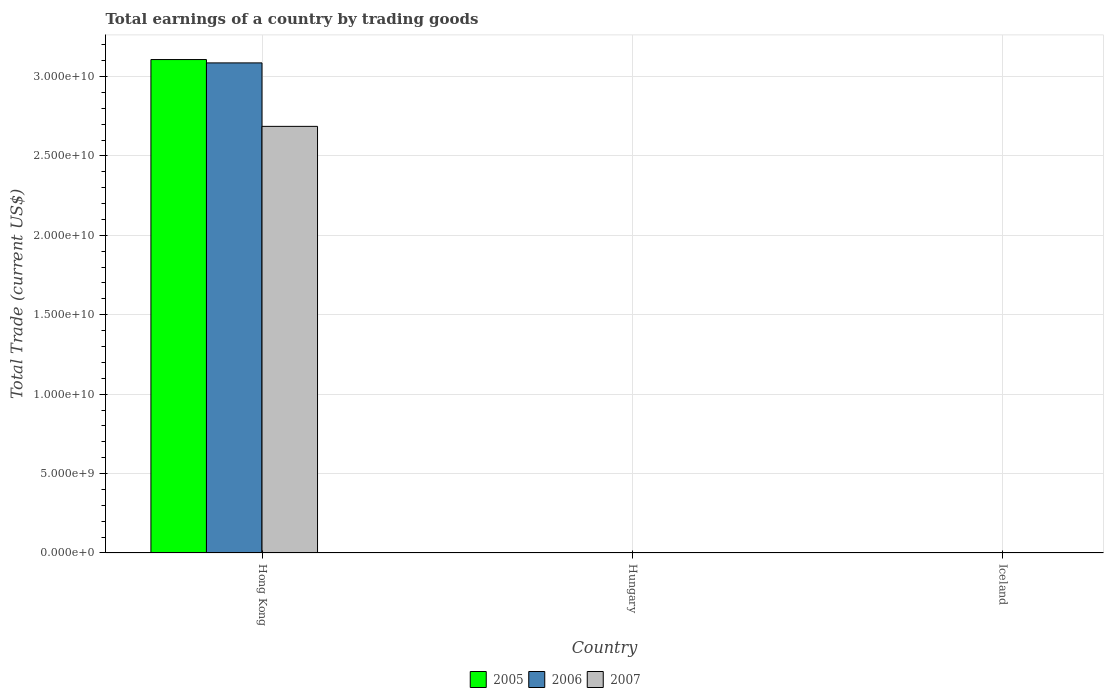Are the number of bars per tick equal to the number of legend labels?
Ensure brevity in your answer.  No. Are the number of bars on each tick of the X-axis equal?
Give a very brief answer. No. How many bars are there on the 3rd tick from the left?
Provide a short and direct response. 0. What is the label of the 1st group of bars from the left?
Your answer should be very brief. Hong Kong. What is the total earnings in 2007 in Hong Kong?
Make the answer very short. 2.69e+1. Across all countries, what is the maximum total earnings in 2006?
Give a very brief answer. 3.09e+1. Across all countries, what is the minimum total earnings in 2006?
Make the answer very short. 0. In which country was the total earnings in 2007 maximum?
Keep it short and to the point. Hong Kong. What is the total total earnings in 2007 in the graph?
Keep it short and to the point. 2.69e+1. What is the difference between the total earnings in 2007 in Iceland and the total earnings in 2005 in Hong Kong?
Make the answer very short. -3.11e+1. What is the average total earnings in 2005 per country?
Your answer should be very brief. 1.04e+1. What is the difference between the total earnings of/in 2005 and total earnings of/in 2006 in Hong Kong?
Offer a very short reply. 2.11e+08. What is the difference between the highest and the lowest total earnings in 2007?
Keep it short and to the point. 2.69e+1. In how many countries, is the total earnings in 2007 greater than the average total earnings in 2007 taken over all countries?
Offer a terse response. 1. How many bars are there?
Your response must be concise. 3. Are all the bars in the graph horizontal?
Offer a terse response. No. Does the graph contain any zero values?
Provide a short and direct response. Yes. How are the legend labels stacked?
Your answer should be compact. Horizontal. What is the title of the graph?
Provide a short and direct response. Total earnings of a country by trading goods. What is the label or title of the Y-axis?
Offer a terse response. Total Trade (current US$). What is the Total Trade (current US$) of 2005 in Hong Kong?
Give a very brief answer. 3.11e+1. What is the Total Trade (current US$) of 2006 in Hong Kong?
Provide a short and direct response. 3.09e+1. What is the Total Trade (current US$) in 2007 in Hong Kong?
Provide a short and direct response. 2.69e+1. What is the Total Trade (current US$) of 2005 in Hungary?
Your answer should be compact. 0. What is the Total Trade (current US$) of 2005 in Iceland?
Make the answer very short. 0. What is the Total Trade (current US$) in 2007 in Iceland?
Your response must be concise. 0. Across all countries, what is the maximum Total Trade (current US$) in 2005?
Make the answer very short. 3.11e+1. Across all countries, what is the maximum Total Trade (current US$) in 2006?
Your answer should be very brief. 3.09e+1. Across all countries, what is the maximum Total Trade (current US$) of 2007?
Give a very brief answer. 2.69e+1. Across all countries, what is the minimum Total Trade (current US$) of 2005?
Give a very brief answer. 0. Across all countries, what is the minimum Total Trade (current US$) in 2006?
Your answer should be very brief. 0. What is the total Total Trade (current US$) in 2005 in the graph?
Your response must be concise. 3.11e+1. What is the total Total Trade (current US$) of 2006 in the graph?
Keep it short and to the point. 3.09e+1. What is the total Total Trade (current US$) of 2007 in the graph?
Keep it short and to the point. 2.69e+1. What is the average Total Trade (current US$) of 2005 per country?
Your answer should be very brief. 1.04e+1. What is the average Total Trade (current US$) in 2006 per country?
Your response must be concise. 1.03e+1. What is the average Total Trade (current US$) in 2007 per country?
Give a very brief answer. 8.95e+09. What is the difference between the Total Trade (current US$) of 2005 and Total Trade (current US$) of 2006 in Hong Kong?
Give a very brief answer. 2.11e+08. What is the difference between the Total Trade (current US$) of 2005 and Total Trade (current US$) of 2007 in Hong Kong?
Provide a short and direct response. 4.21e+09. What is the difference between the Total Trade (current US$) in 2006 and Total Trade (current US$) in 2007 in Hong Kong?
Provide a succinct answer. 4.00e+09. What is the difference between the highest and the lowest Total Trade (current US$) of 2005?
Your response must be concise. 3.11e+1. What is the difference between the highest and the lowest Total Trade (current US$) of 2006?
Offer a terse response. 3.09e+1. What is the difference between the highest and the lowest Total Trade (current US$) of 2007?
Your answer should be very brief. 2.69e+1. 